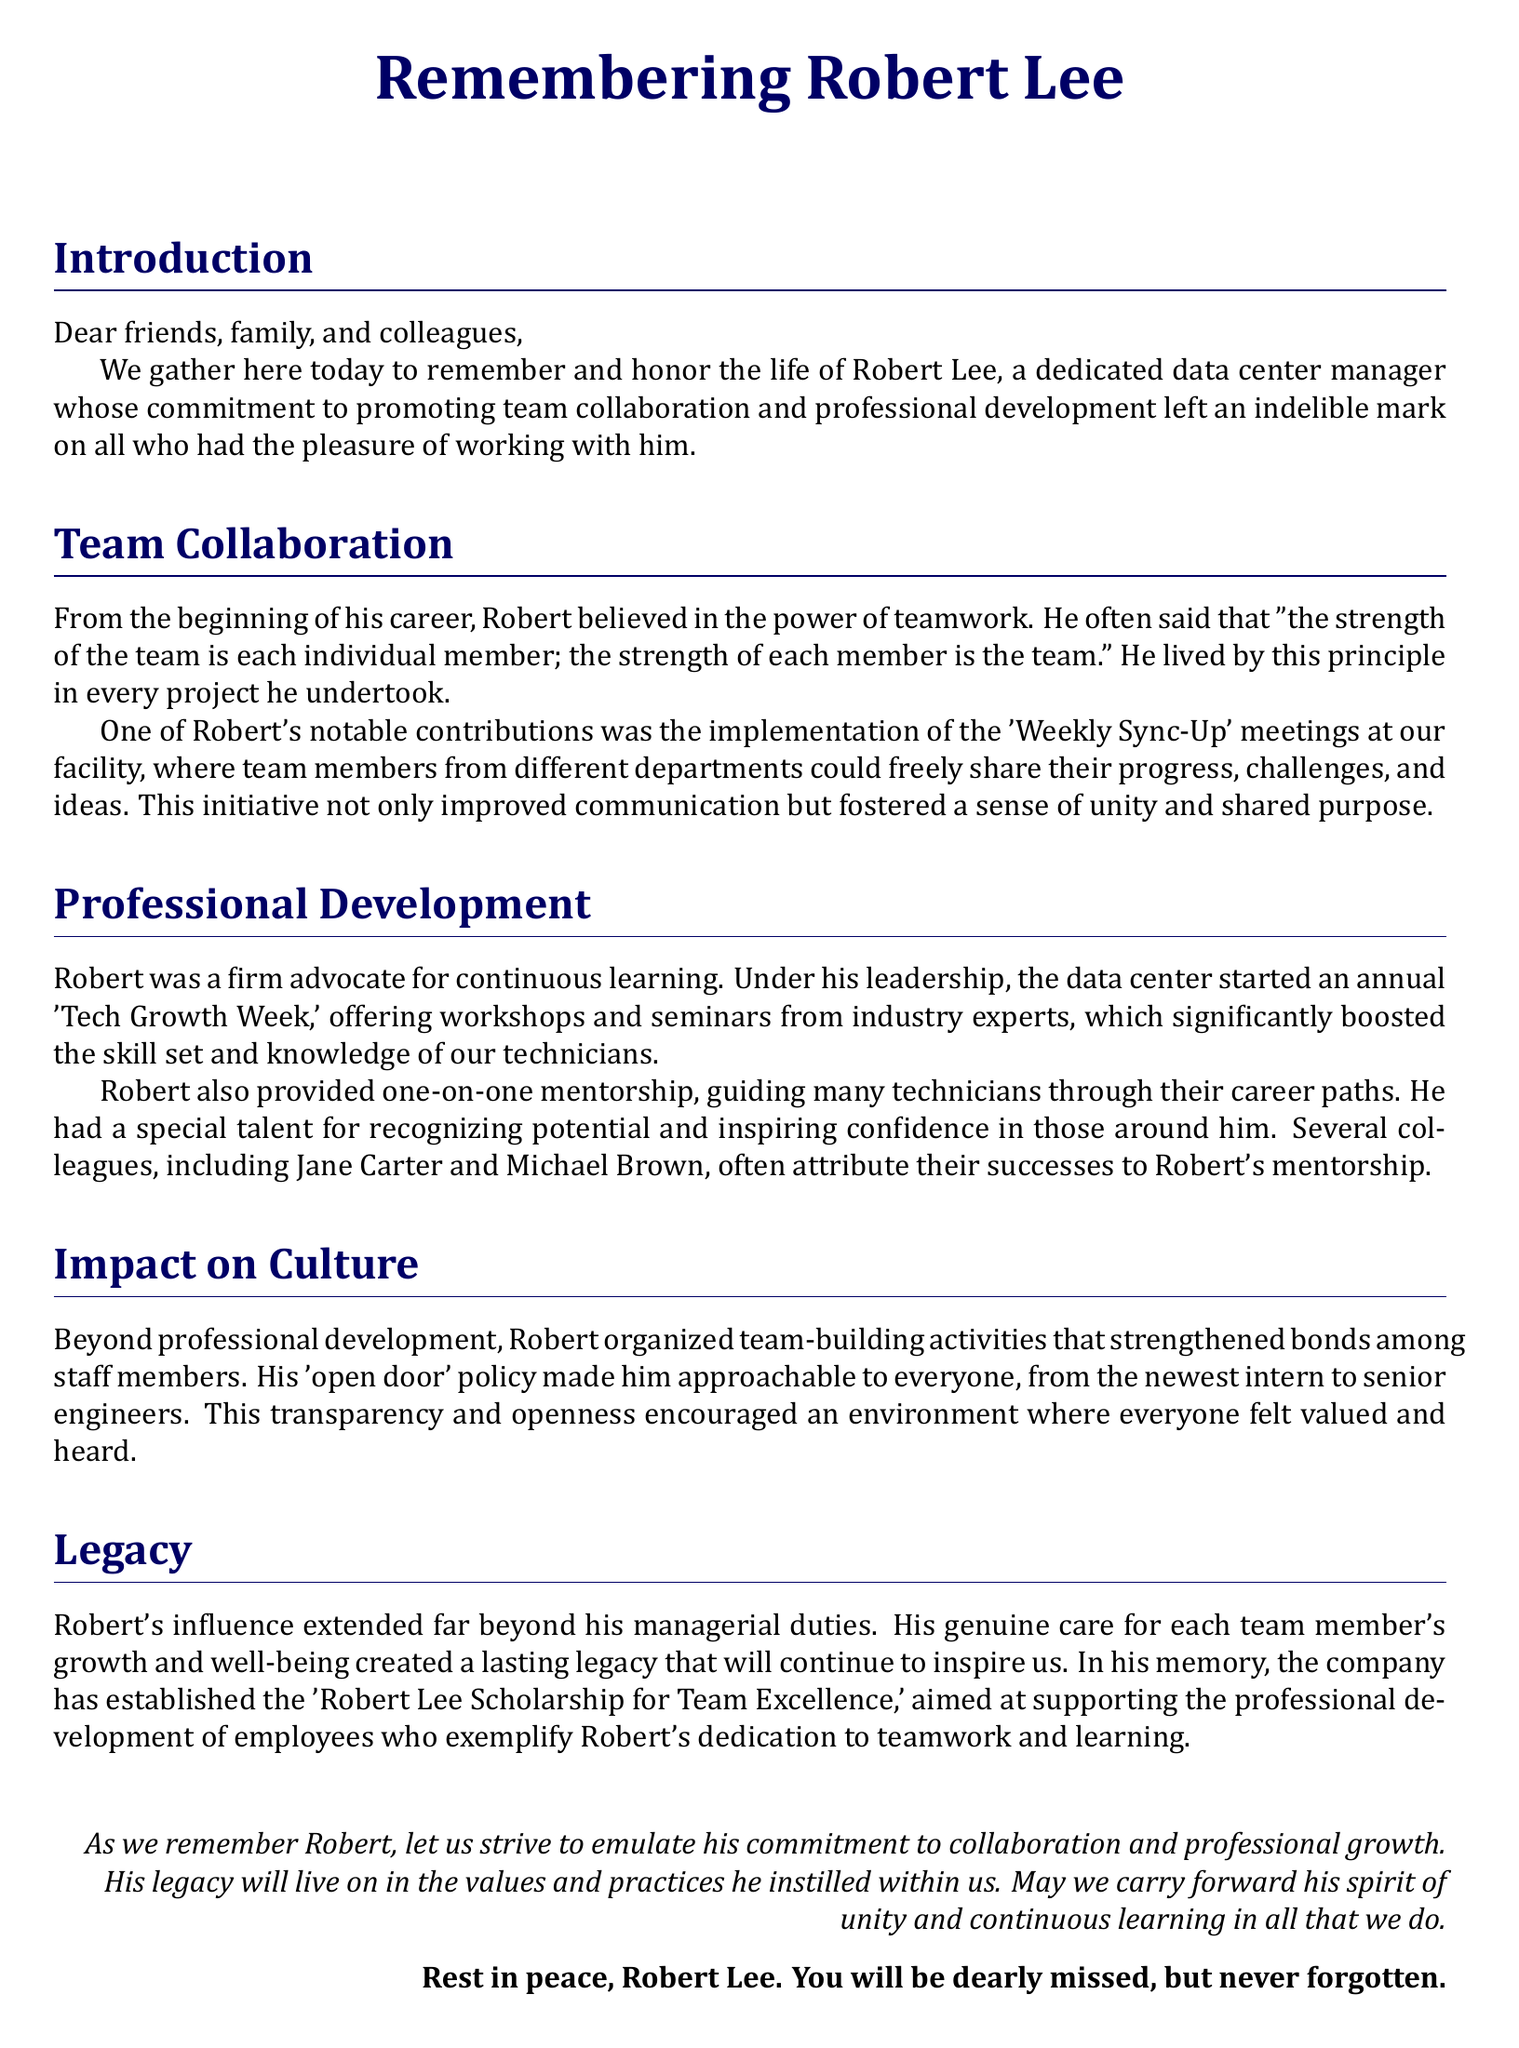what was Robert Lee's belief about teamwork? Robert believed in the power of teamwork and said, "the strength of the team is each individual member; the strength of each member is the team."
Answer: teamwork strength what initiative did Robert implement for team collaboration? Robert implemented the 'Weekly Sync-Up' meetings to improve communication and foster unity among team members.
Answer: Weekly Sync-Up meetings what annual event did Robert start to promote professional development? Robert started the 'Tech Growth Week,' which offered workshops and seminars to enhance skills and knowledge.
Answer: Tech Growth Week who were the colleagues that attributed their success to Robert's mentorship? Jane Carter and Michael Brown often attribute their successes to Robert's mentorship.
Answer: Jane Carter and Michael Brown what type of policy did Robert have to encourage approachability? Robert had an 'open door' policy that made him approachable to all staff members.
Answer: open door policy what scholarship was established in Robert's memory? The 'Robert Lee Scholarship for Team Excellence' was established to support professional development of employees.
Answer: Robert Lee Scholarship for Team Excellence how did Robert's leadership impact the culture of the workplace? His leadership created a lasting legacy of care for each team member's growth and well-being.
Answer: lasting legacy what was a notable characteristic of Robert's mentorship style? Robert had a special talent for recognizing potential and inspiring confidence in those around him.
Answer: recognition and inspiration 